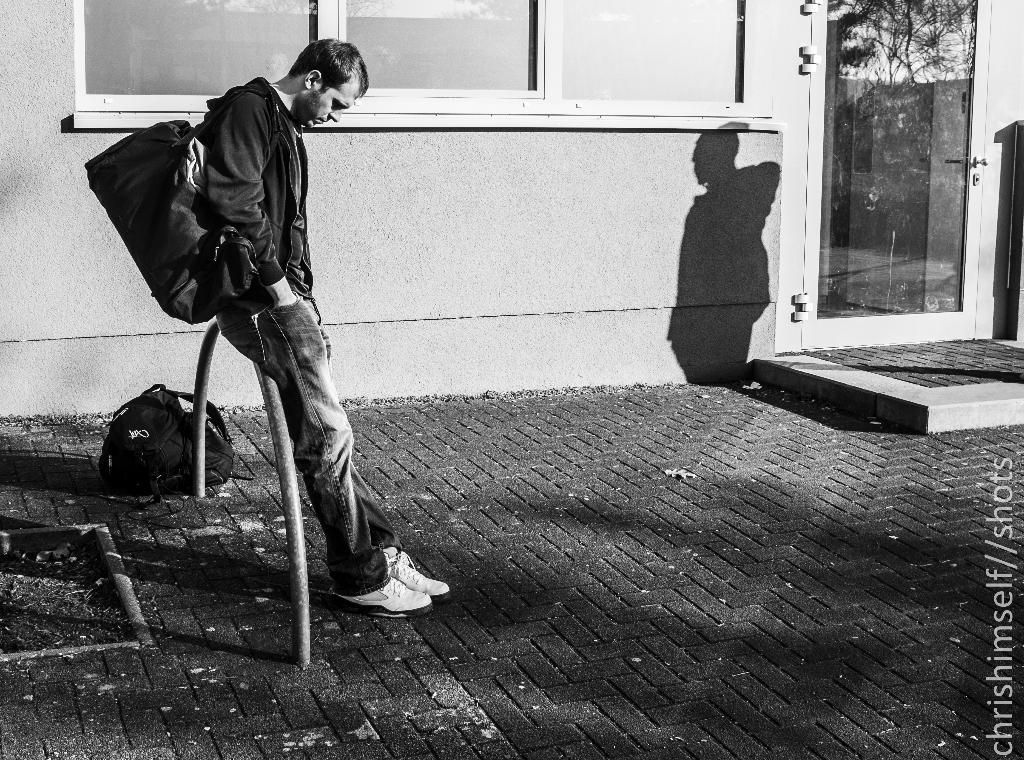What type of structure can be seen in the image? There is a wall in the image. What architectural feature is present in the wall? There is a window in the image. Is there another entrance visible in the image? Yes, there is a door in the image. What color is the bag that is visible in the image? The bag in the image is black. Who is present in the image? There is a person in the image. What is the person wearing? The person is wearing a black color jacket. What is the person carrying in the image? The person is carrying a bag. How does the person in the image start trouble with the expansion of the wall? There is no indication in the image that the person is starting trouble or that the wall is expanding. 